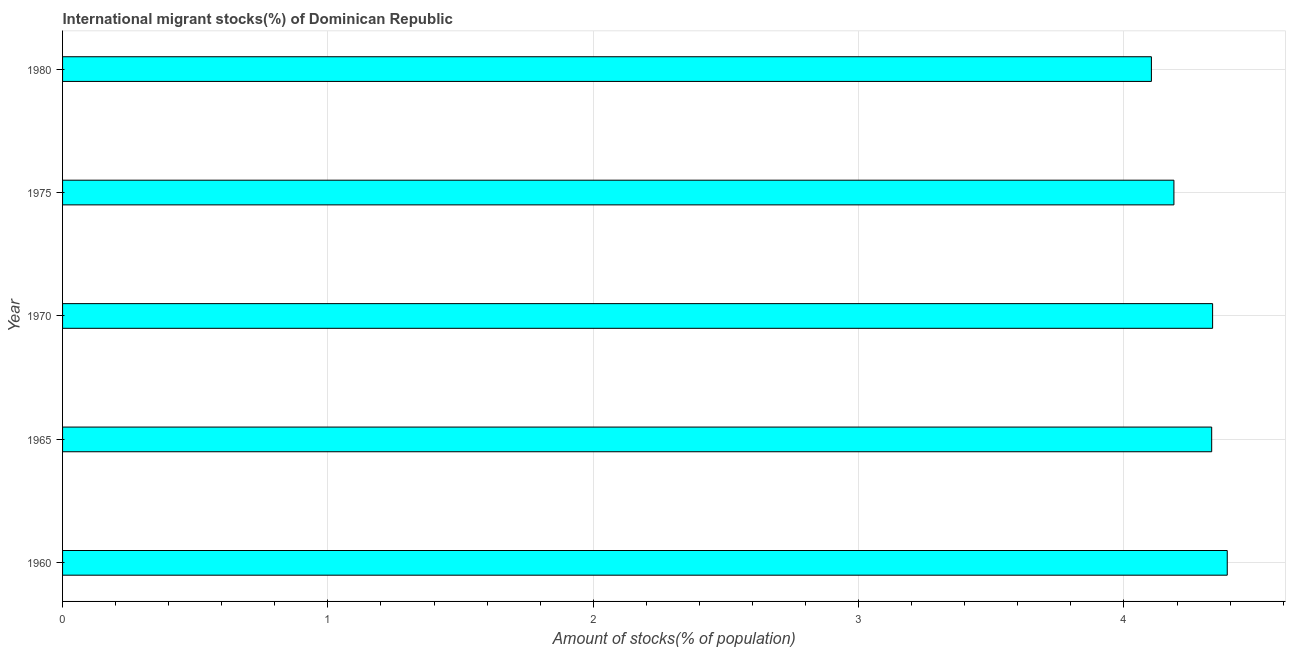Does the graph contain any zero values?
Offer a terse response. No. Does the graph contain grids?
Keep it short and to the point. Yes. What is the title of the graph?
Keep it short and to the point. International migrant stocks(%) of Dominican Republic. What is the label or title of the X-axis?
Ensure brevity in your answer.  Amount of stocks(% of population). What is the label or title of the Y-axis?
Your response must be concise. Year. What is the number of international migrant stocks in 1960?
Ensure brevity in your answer.  4.39. Across all years, what is the maximum number of international migrant stocks?
Your response must be concise. 4.39. Across all years, what is the minimum number of international migrant stocks?
Your response must be concise. 4.1. In which year was the number of international migrant stocks minimum?
Your answer should be very brief. 1980. What is the sum of the number of international migrant stocks?
Provide a short and direct response. 21.35. What is the difference between the number of international migrant stocks in 1965 and 1975?
Offer a terse response. 0.14. What is the average number of international migrant stocks per year?
Give a very brief answer. 4.27. What is the median number of international migrant stocks?
Provide a short and direct response. 4.33. In how many years, is the number of international migrant stocks greater than 1.8 %?
Give a very brief answer. 5. Do a majority of the years between 1965 and 1975 (inclusive) have number of international migrant stocks greater than 0.4 %?
Provide a short and direct response. Yes. What is the ratio of the number of international migrant stocks in 1960 to that in 1970?
Your answer should be compact. 1.01. Is the number of international migrant stocks in 1960 less than that in 1965?
Offer a terse response. No. Is the difference between the number of international migrant stocks in 1960 and 1965 greater than the difference between any two years?
Make the answer very short. No. What is the difference between the highest and the second highest number of international migrant stocks?
Make the answer very short. 0.06. Is the sum of the number of international migrant stocks in 1965 and 1980 greater than the maximum number of international migrant stocks across all years?
Give a very brief answer. Yes. What is the difference between the highest and the lowest number of international migrant stocks?
Your response must be concise. 0.29. In how many years, is the number of international migrant stocks greater than the average number of international migrant stocks taken over all years?
Make the answer very short. 3. What is the Amount of stocks(% of population) of 1960?
Provide a short and direct response. 4.39. What is the Amount of stocks(% of population) of 1965?
Make the answer very short. 4.33. What is the Amount of stocks(% of population) in 1970?
Give a very brief answer. 4.33. What is the Amount of stocks(% of population) of 1975?
Your answer should be very brief. 4.19. What is the Amount of stocks(% of population) in 1980?
Ensure brevity in your answer.  4.1. What is the difference between the Amount of stocks(% of population) in 1960 and 1965?
Your answer should be very brief. 0.06. What is the difference between the Amount of stocks(% of population) in 1960 and 1970?
Offer a terse response. 0.06. What is the difference between the Amount of stocks(% of population) in 1960 and 1975?
Give a very brief answer. 0.2. What is the difference between the Amount of stocks(% of population) in 1960 and 1980?
Provide a succinct answer. 0.29. What is the difference between the Amount of stocks(% of population) in 1965 and 1970?
Offer a terse response. -0. What is the difference between the Amount of stocks(% of population) in 1965 and 1975?
Provide a succinct answer. 0.14. What is the difference between the Amount of stocks(% of population) in 1965 and 1980?
Offer a very short reply. 0.23. What is the difference between the Amount of stocks(% of population) in 1970 and 1975?
Offer a terse response. 0.15. What is the difference between the Amount of stocks(% of population) in 1970 and 1980?
Your answer should be very brief. 0.23. What is the difference between the Amount of stocks(% of population) in 1975 and 1980?
Make the answer very short. 0.08. What is the ratio of the Amount of stocks(% of population) in 1960 to that in 1965?
Keep it short and to the point. 1.01. What is the ratio of the Amount of stocks(% of population) in 1960 to that in 1975?
Provide a succinct answer. 1.05. What is the ratio of the Amount of stocks(% of population) in 1960 to that in 1980?
Offer a terse response. 1.07. What is the ratio of the Amount of stocks(% of population) in 1965 to that in 1975?
Keep it short and to the point. 1.03. What is the ratio of the Amount of stocks(% of population) in 1965 to that in 1980?
Ensure brevity in your answer.  1.05. What is the ratio of the Amount of stocks(% of population) in 1970 to that in 1975?
Your answer should be compact. 1.03. What is the ratio of the Amount of stocks(% of population) in 1970 to that in 1980?
Keep it short and to the point. 1.06. What is the ratio of the Amount of stocks(% of population) in 1975 to that in 1980?
Your answer should be compact. 1.02. 